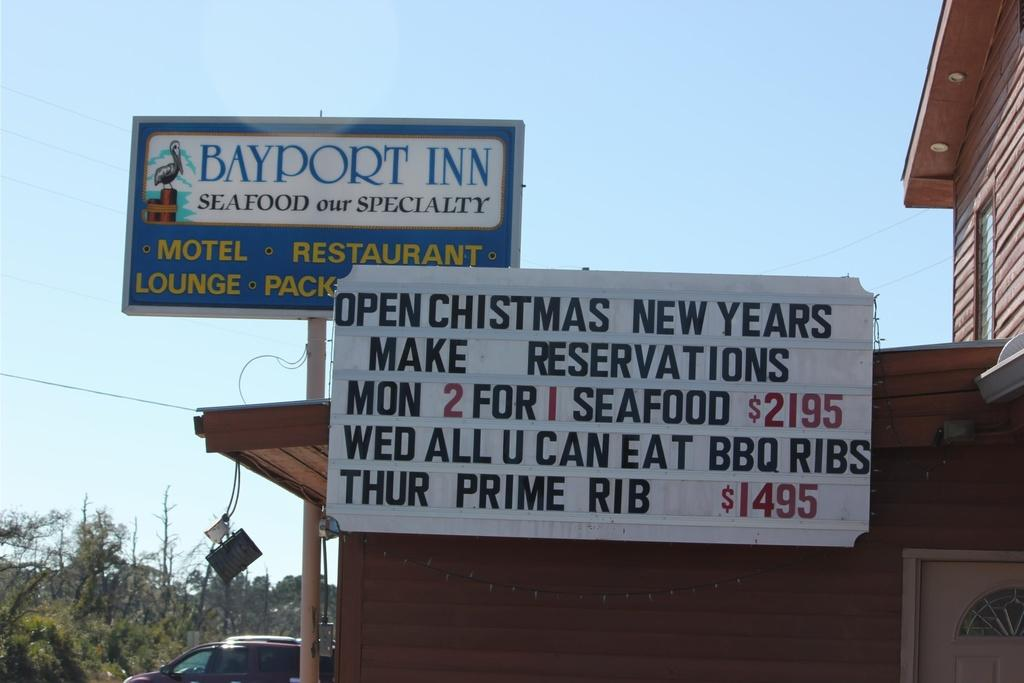What type of structure is visible in the image? There is a building in the image. What else can be seen in the image besides the building? There is a vehicle, name boards, trees, some objects, and the sky visible in the image. Can you describe the vehicle in the image? Unfortunately, the facts provided do not give enough information to describe the vehicle in detail. What is the background of the image? The sky is visible in the background of the image. What type of chin can be seen on the building in the image? There is no chin present on the building in the image, as a chin is a part of the human face and not a feature of a building. 